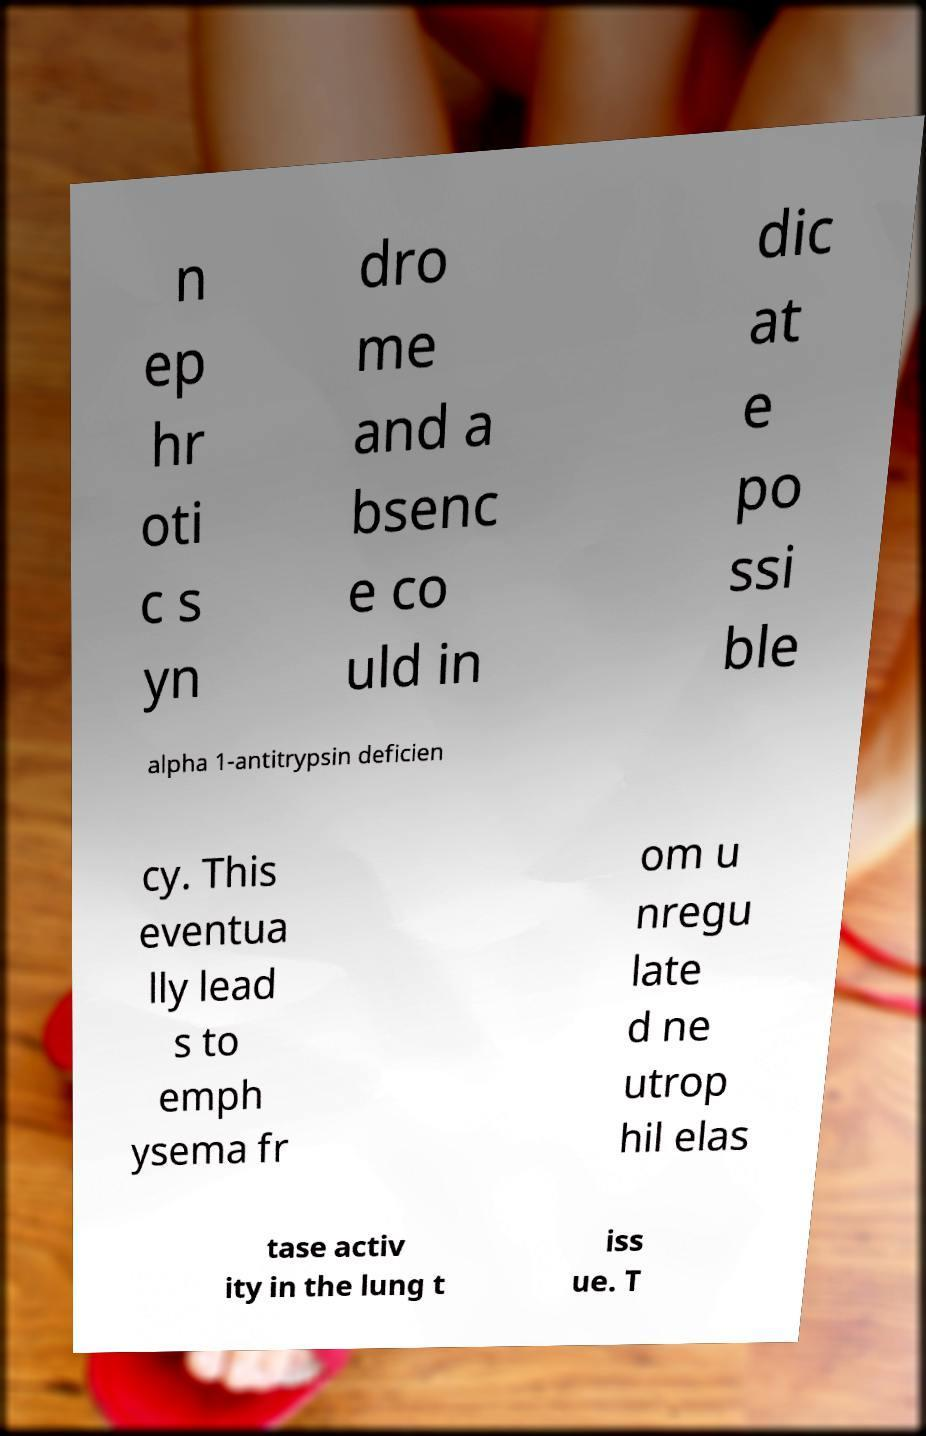Please read and relay the text visible in this image. What does it say? n ep hr oti c s yn dro me and a bsenc e co uld in dic at e po ssi ble alpha 1-antitrypsin deficien cy. This eventua lly lead s to emph ysema fr om u nregu late d ne utrop hil elas tase activ ity in the lung t iss ue. T 